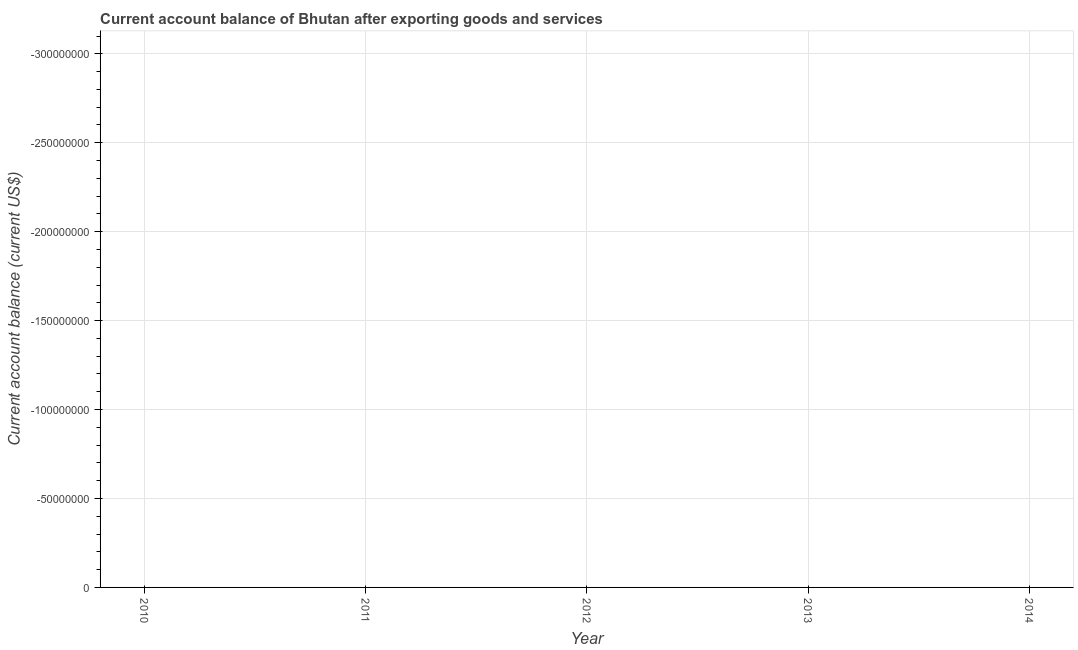What is the median current account balance?
Provide a short and direct response. 0. In how many years, is the current account balance greater than -180000000 US$?
Keep it short and to the point. 0. Does the current account balance monotonically increase over the years?
Make the answer very short. No. How many years are there in the graph?
Offer a very short reply. 5. Does the graph contain grids?
Your answer should be compact. Yes. What is the title of the graph?
Provide a succinct answer. Current account balance of Bhutan after exporting goods and services. What is the label or title of the Y-axis?
Offer a terse response. Current account balance (current US$). What is the Current account balance (current US$) of 2011?
Your answer should be very brief. 0. What is the Current account balance (current US$) of 2014?
Offer a terse response. 0. 